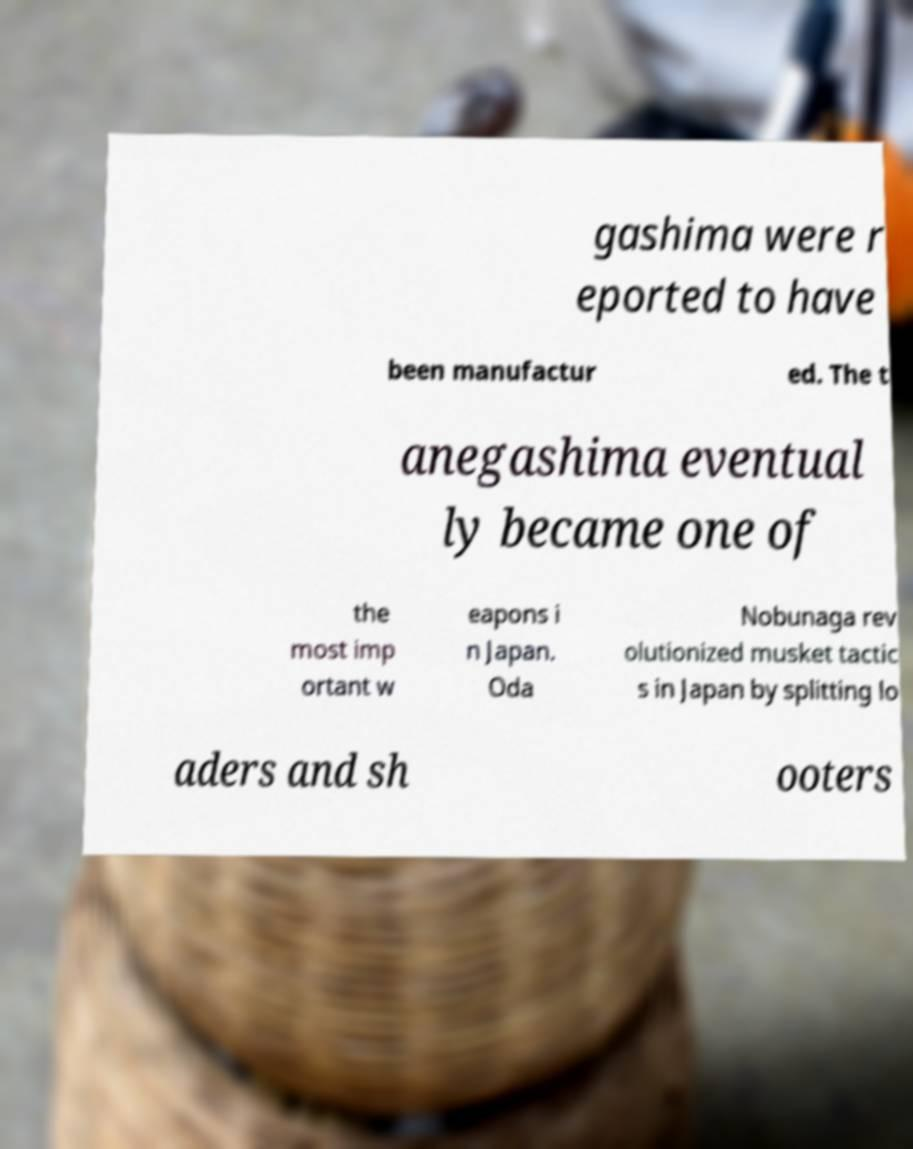Please identify and transcribe the text found in this image. gashima were r eported to have been manufactur ed. The t anegashima eventual ly became one of the most imp ortant w eapons i n Japan. Oda Nobunaga rev olutionized musket tactic s in Japan by splitting lo aders and sh ooters 